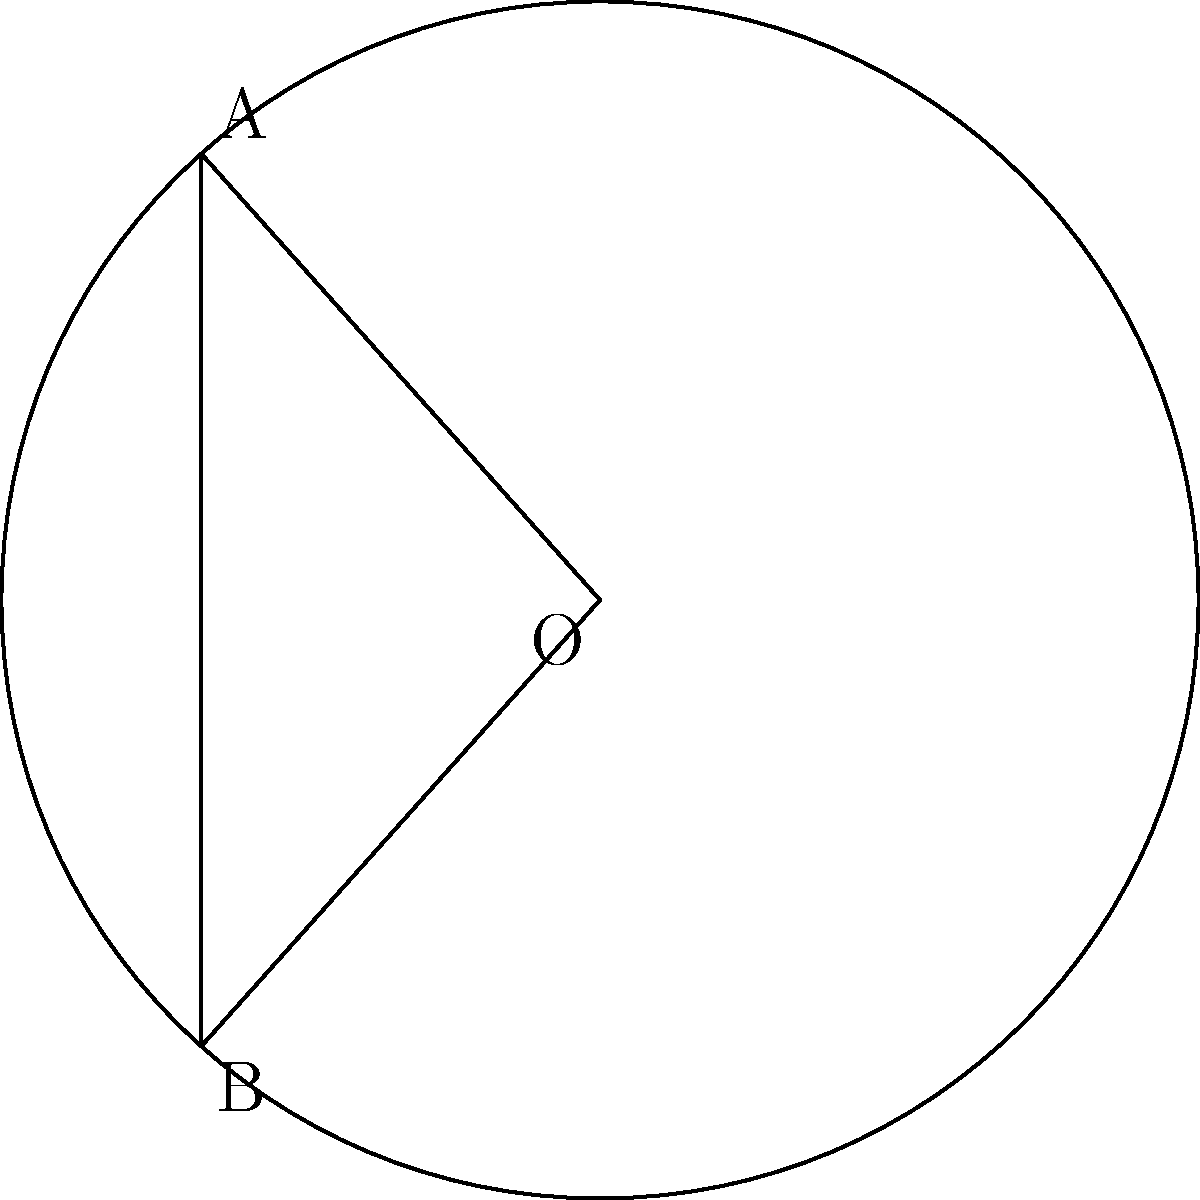In a circular segment, the chord length is $c = 4$ units and the radius of the circle is $r = 3$ units. Calculate the area of the circular segment. Round your answer to two decimal places. To find the area of a circular segment, we'll follow these steps:

1) First, we need to find the central angle $\theta$ (in radians):
   $$\cos(\theta/2) = \frac{c/2}{r} = \frac{4/2}{3} = \frac{2}{3}$$
   $$\theta = 2 \arccos(\frac{2}{3}) \approx 1.8091$$

2) The area of a circular sector with angle $\theta$ is:
   $$A_{sector} = \frac{1}{2}r^2\theta$$

3) The area of the triangle formed by the chord and the two radii is:
   $$A_{triangle} = \frac{1}{2}r^2\sin(\theta)$$

4) The area of the segment is the difference between these:
   $$A_{segment} = A_{sector} - A_{triangle}$$
   $$= \frac{1}{2}r^2\theta - \frac{1}{2}r^2\sin(\theta)$$
   $$= \frac{1}{2}r^2(\theta - \sin(\theta))$$

5) Substituting the values:
   $$A_{segment} = \frac{1}{2} \cdot 3^2 \cdot (1.8091 - \sin(1.8091))$$
   $$\approx 1.4556$$

6) Rounding to two decimal places:
   $$A_{segment} \approx 1.46$$

This problem demonstrates the use of trigonometry and geometry in a way that's relevant to software engineering, particularly when working with mathematical libraries or graphics programming.
Answer: $1.46$ square units 